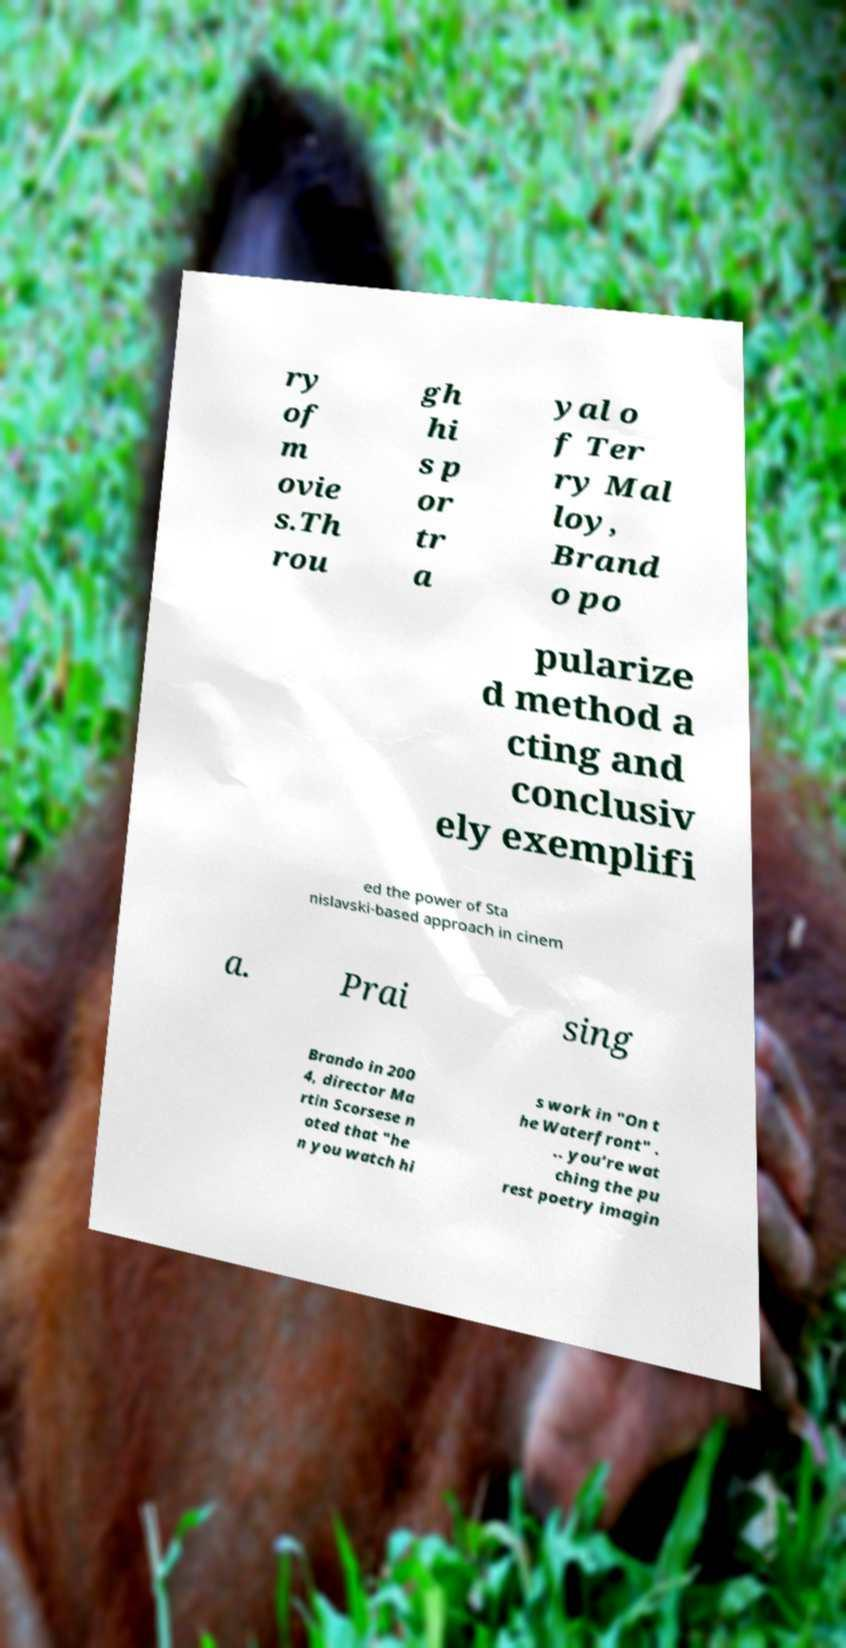What messages or text are displayed in this image? I need them in a readable, typed format. ry of m ovie s.Th rou gh hi s p or tr a yal o f Ter ry Mal loy, Brand o po pularize d method a cting and conclusiv ely exemplifi ed the power of Sta nislavski-based approach in cinem a. Prai sing Brando in 200 4, director Ma rtin Scorsese n oted that "he n you watch hi s work in "On t he Waterfront" . .. you’re wat ching the pu rest poetry imagin 